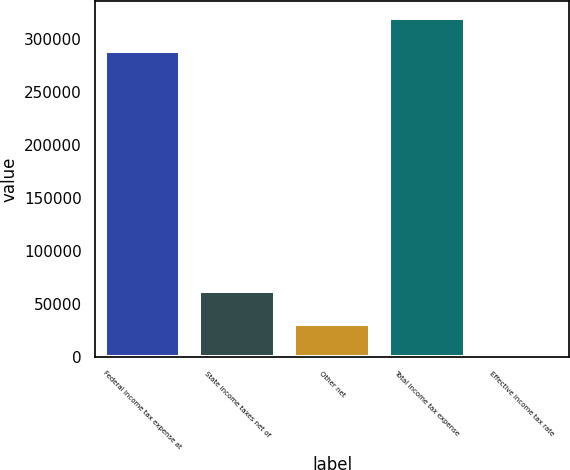Convert chart to OTSL. <chart><loc_0><loc_0><loc_500><loc_500><bar_chart><fcel>Federal income tax expense at<fcel>State income taxes net of<fcel>Other net<fcel>Total income tax expense<fcel>Effective income tax rate<nl><fcel>289107<fcel>61961.8<fcel>30999.7<fcel>320069<fcel>37.5<nl></chart> 